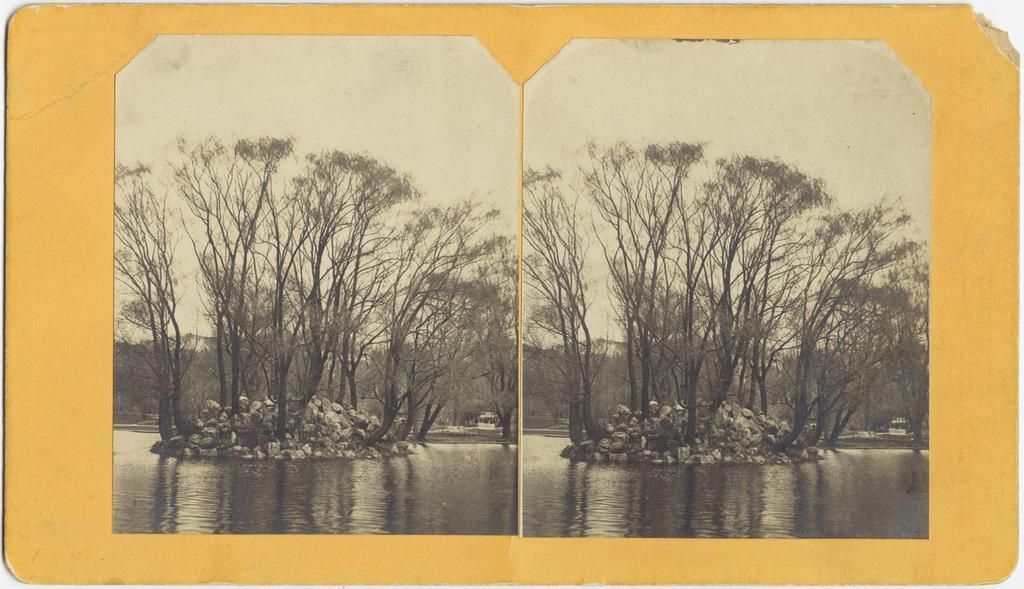Could you give a brief overview of what you see in this image? This is a collage image. Here I can see two images of same view. In this image I can see the water. In the background there are some rocks and trees. On the top of the image I can see the sky. 